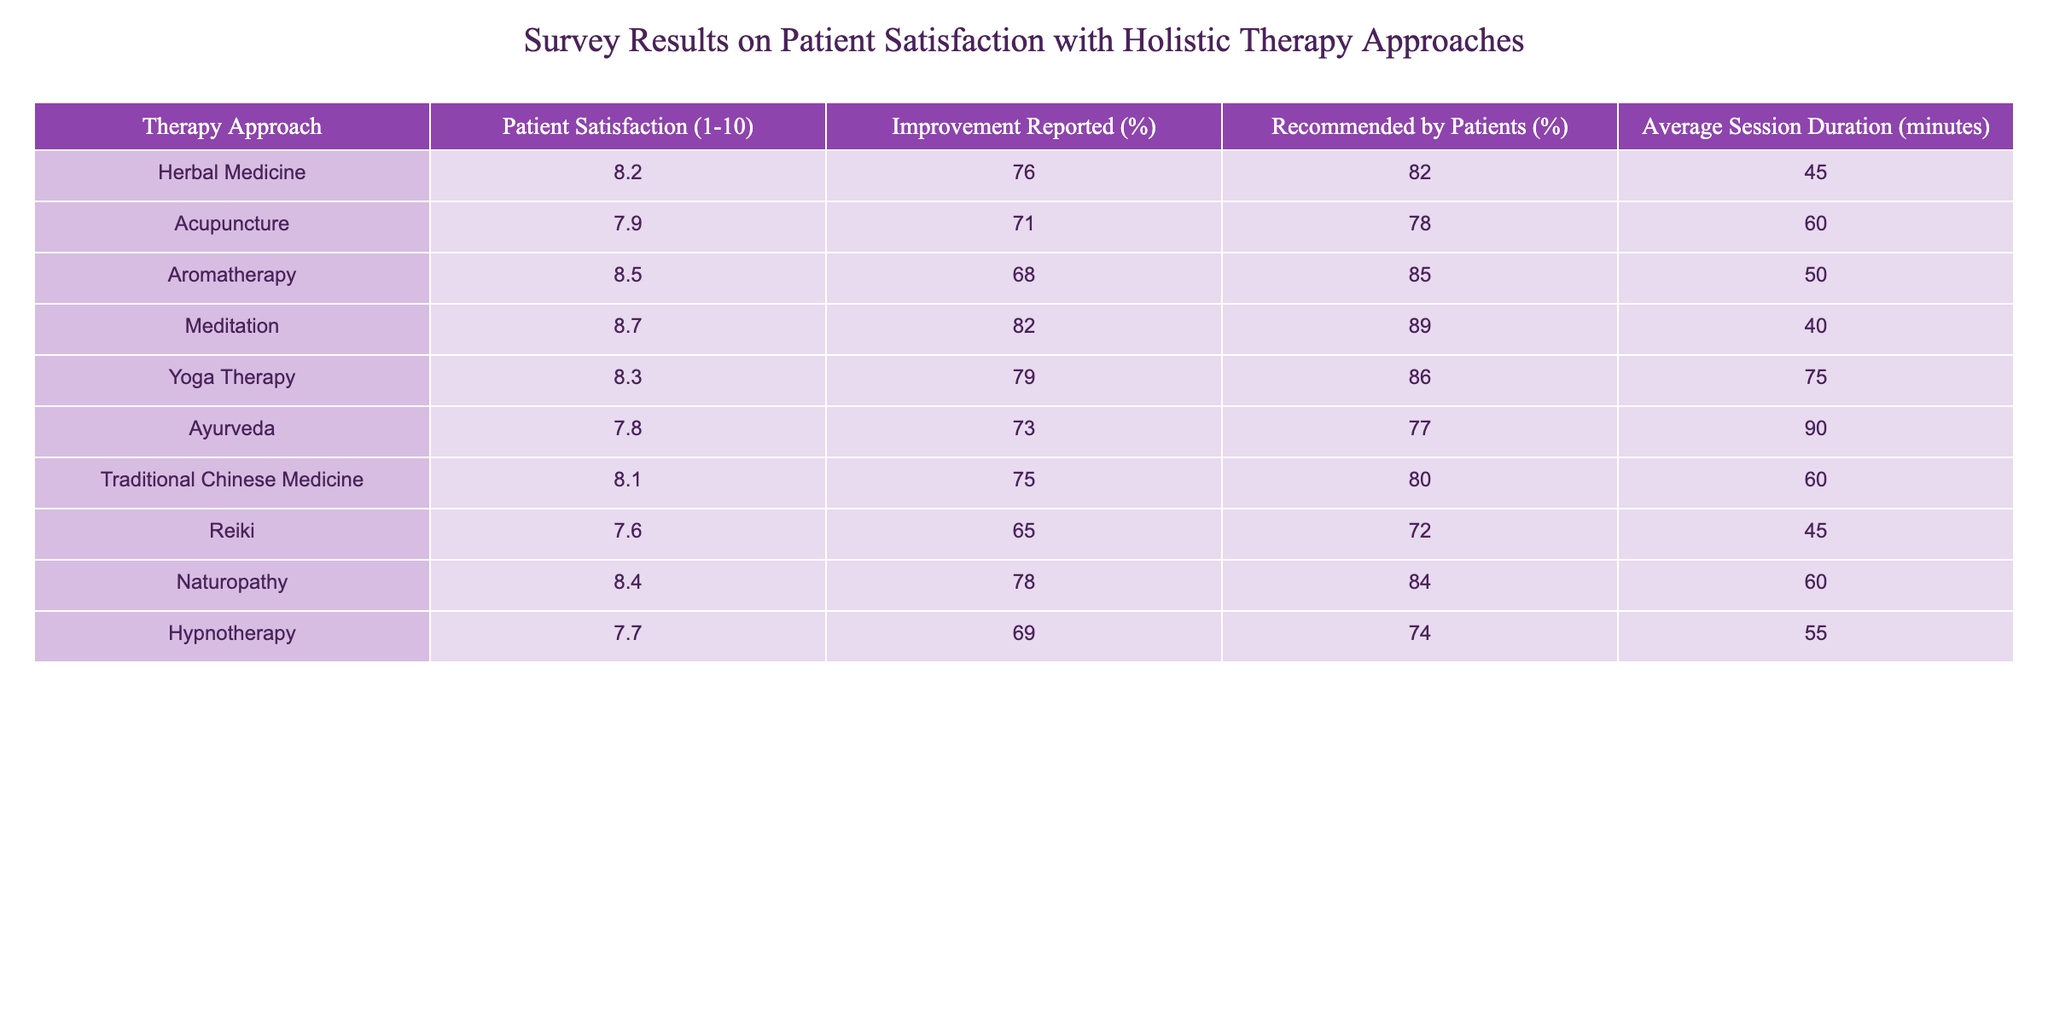What is the highest patient satisfaction score among the therapy approaches? The table lists satisfaction scores for each therapy approach. The highest score is 8.7 for Meditation.
Answer: 8.7 Which therapy approach has the lowest improvement reported percentage? The improvement reported percentage is given for each therapy approach. The lowest percentage is 65% for Reiki.
Answer: 65% What is the average session duration for Yoga Therapy? The session duration for Yoga Therapy is explicitly listed in the table as 75 minutes.
Answer: 75 minutes How many therapy approaches have a patient satisfaction score of 8 or higher? The patient satisfaction scores are: 8.2, 7.9, 8.5, 8.7, 8.3, 7.8, 8.1, 7.6, 8.4, 7.7. Counting those 8 or above gives us 5 approaches: Herbal Medicine, Aromatherapy, Meditation, Yoga Therapy, and Naturopathy.
Answer: 5 Is the statement "Acupuncture is recommended by 78% of patients" true? The table shows that Acupuncture is indeed recommended by 78% of patients, confirming the statement is correct.
Answer: Yes What is the difference in improvement reported percentage between Meditation and Ayurveda? The improvement reported percentages are 82% for Meditation and 73% for Ayurveda. Calculating the difference: 82 - 73 = 9%.
Answer: 9% Which therapy approach has the highest percentage of patients recommending it? The percentages of patients recommending each therapy approach are given. Aromatherapy has the highest at 85%.
Answer: 85% What is the average patient satisfaction score for all therapy approaches? Adding up the satisfaction scores: (8.2 + 7.9 + 8.5 + 8.7 + 8.3 + 7.8 + 8.1 + 7.6 + 8.4 + 7.7) = 87.2 and dividing by 10 (the number of approaches) gives an average of 8.72.
Answer: 8.72 Do most patients report improvement with Reiki? The improvement percentage for Reiki is 65%, which is not considered most, as it is below 70%. Thus, the statement is false.
Answer: No Which therapy has the longest average session duration? The average session durations are: 45, 60, 50, 40, 75, 90, 60, 45, 60, and 55 minutes respectively. The longest duration is 90 minutes for Ayurveda.
Answer: 90 minutes 